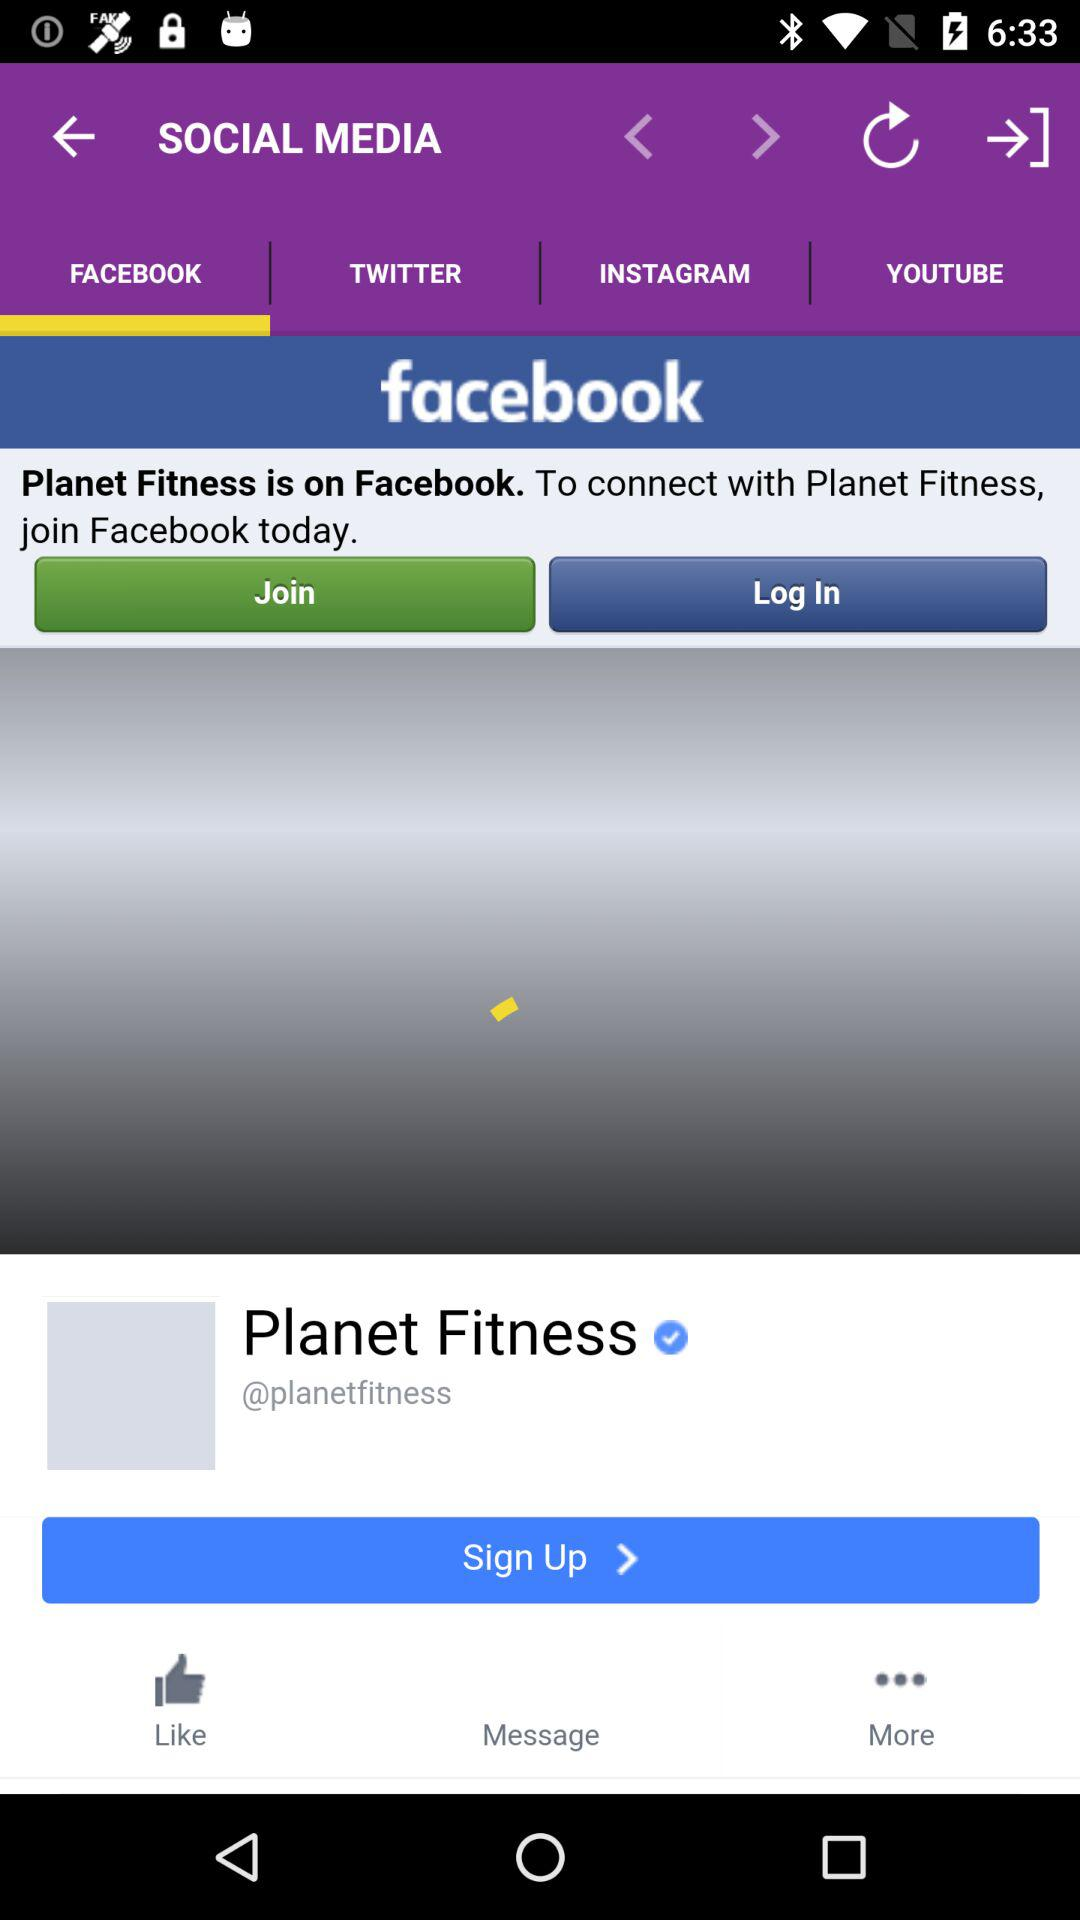What is the name of the page? The name of the page is "Planet Fitness". 